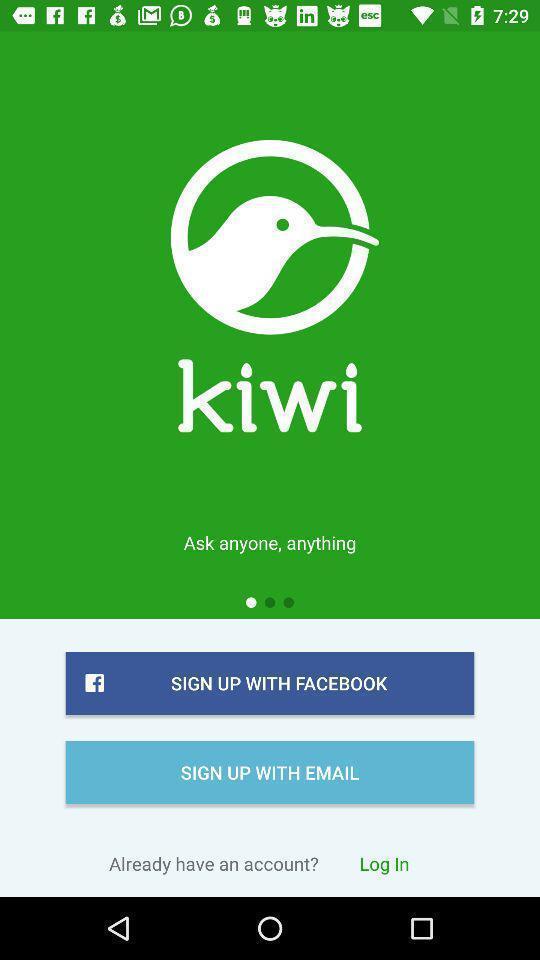What can you discern from this picture? Sign up page for a travel app. 